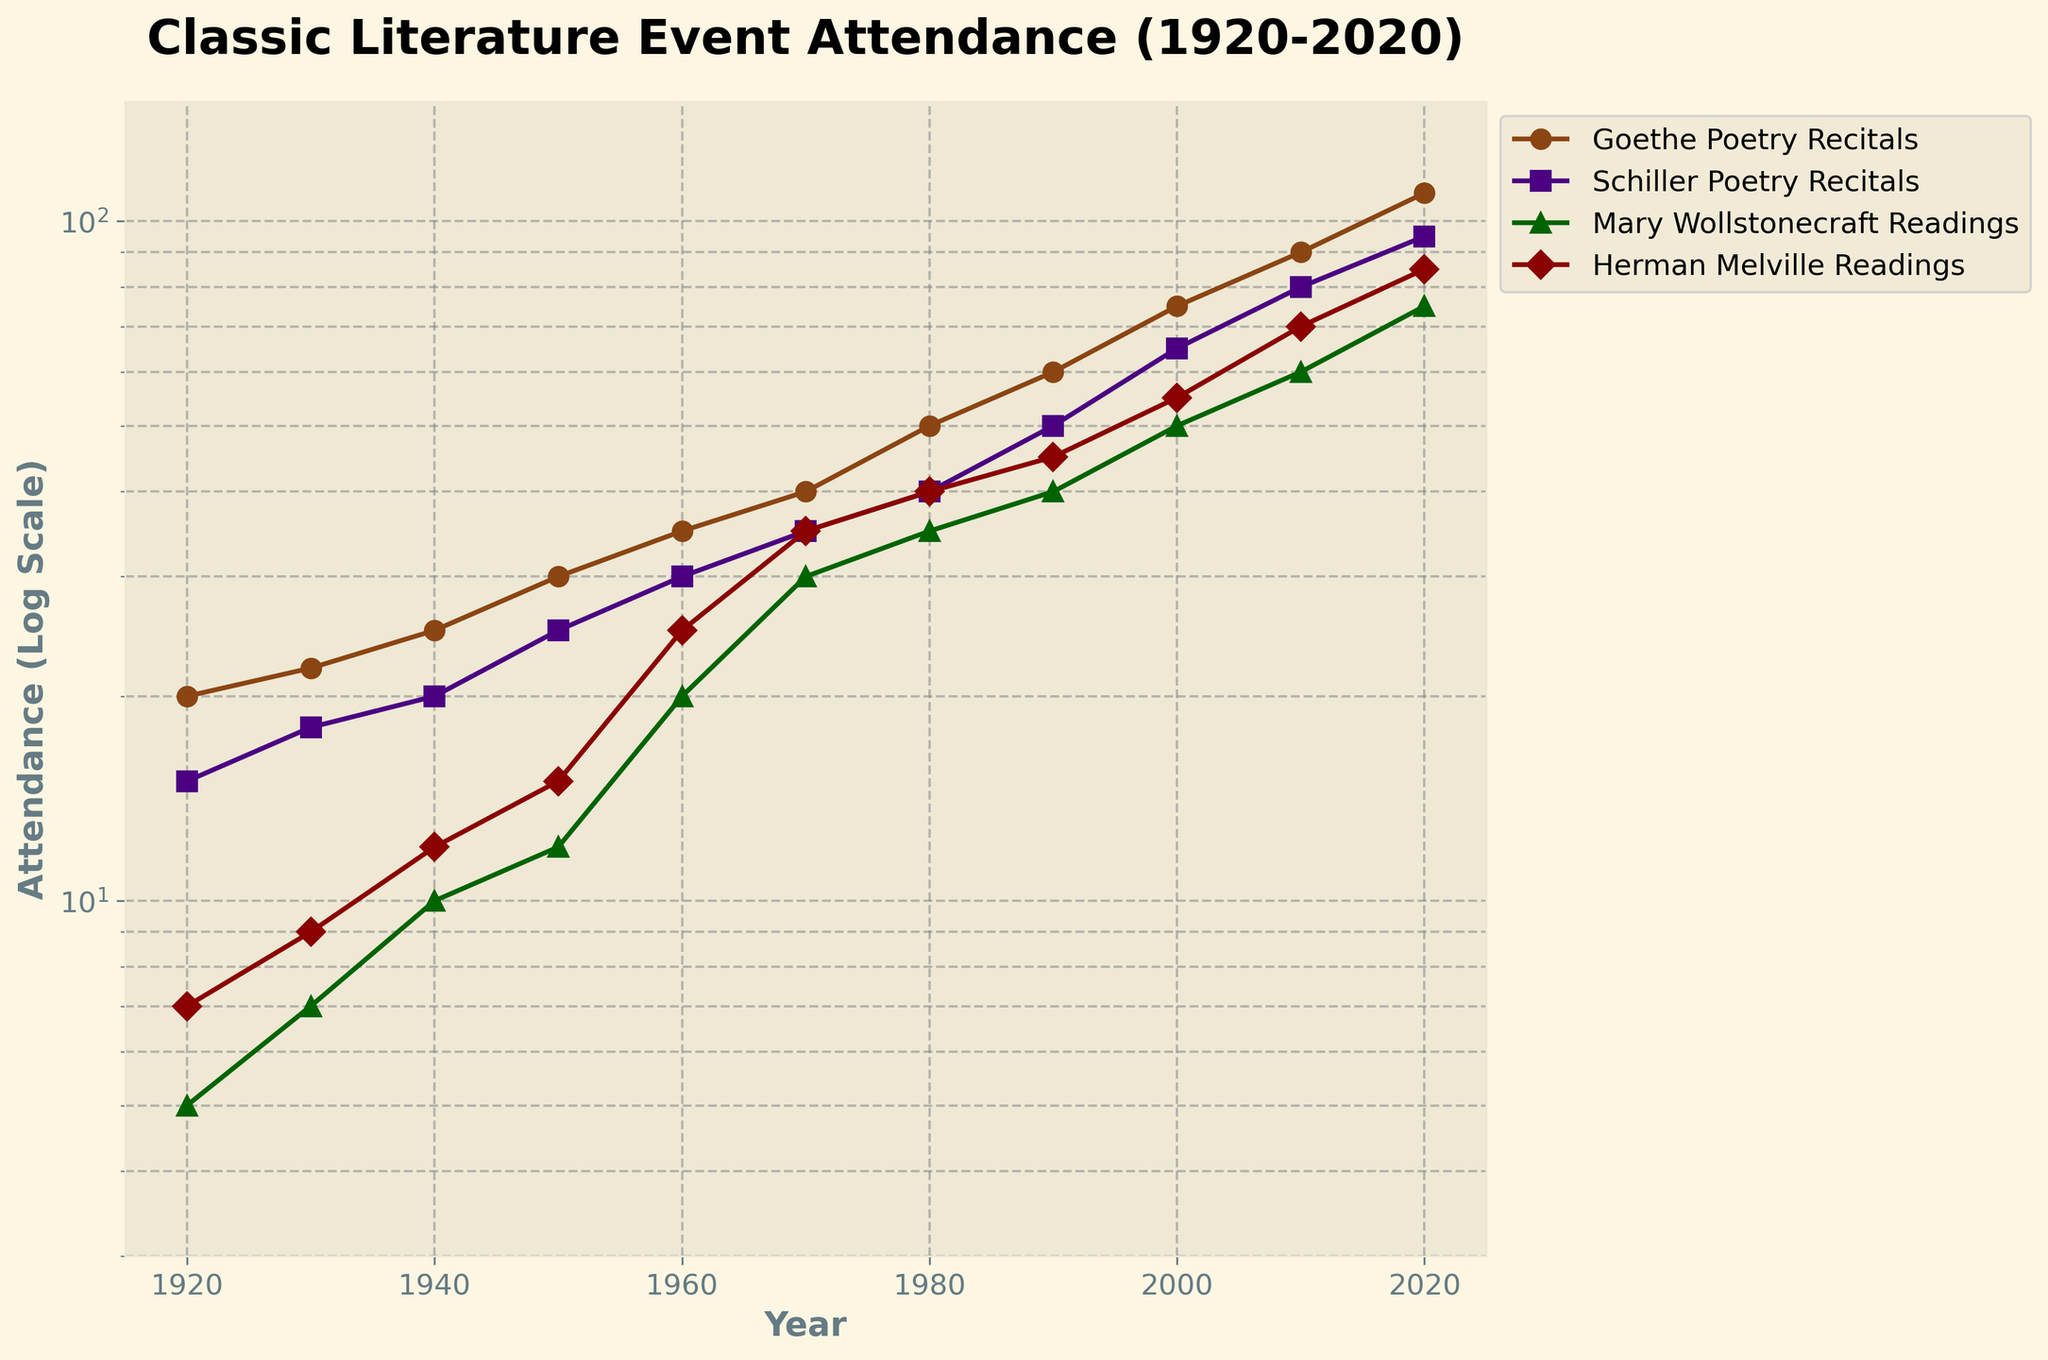What is the title of the figure? The title of the figure is shown at the top and clearly states the focus of the plot.
Answer: Classic Literature Event Attendance (1920-2020) What are the labels on the x-axis and y-axis? The labels on the axes are located beside each axis, with the x-axis label typically at the bottom and the y-axis label to the left of the plot.
Answer: Year (x-axis), Attendance (Log Scale) (y-axis) Which event had the highest attendance in 2020? By examining the values at the far right of the plot (year 2020), you can determine which line reaches the highest point.
Answer: Goethe Poetry Recitals What is the general trend of attendance for Mary Wollstonecraft Readings over the century? By tracking the line associated with Mary Wollstonecraft Readings from 1920 to 2020, one can observe whether it is generally increasing, decreasing, or stable.
Answer: Increasing How does the attendance of Schiller Poetry Recitals in 1960 compare to Herman Melville Readings in the same year? Find the points for Schiller Poetry Recitals and Herman Melville Readings in 1960 and compare their heights on the plot.
Answer: Schiller Poetry Recitals had higher attendance What is the difference in attendance between Goethe Poetry Recitals and Mary Wollstonecraft Readings in 2020? Locate the points for both Goethe Poetry Recitals and Mary Wollstonecraft Readings in 2020, then subtract the attendance value of Mary Wollstonecraft Readings from Goethe Poetry Recitals.
Answer: 35 During which decade did Herman Melville Readings surpass 30 attendants? Track the line for Herman Melville Readings and identify the first decade where its value crosses the 30 mark on the y-axis.
Answer: 1970s By what factor did Goethe Poetry Recitals' attendance increase from 1920 to 2020? Compare the attendance values of Goethe Poetry Recitals in 1920 and 2020 and calculate the factor by dividing the value in 2020 by the value in 1920.
Answer: 5.5 What is the average attendance for Schiller Poetry Recitals over the last century? Sum the attendance values for Schiller Poetry Recitals from 1920 to 2020 and divide by the number of data points (11).
Answer: 46.36 How does the growth trend of Mary Wollstonecraft Readings compare to Herman Melville Readings from 2000 to 2020? Observe the lines representing Mary Wollstonecraft Readings and Herman Melville Readings between 2000 and 2020 to see if the slopes are increasing at the same rate, faster, or slower.
Answer: Mary Wollstonecraft Readings grew slower than Herman Melville Readings 